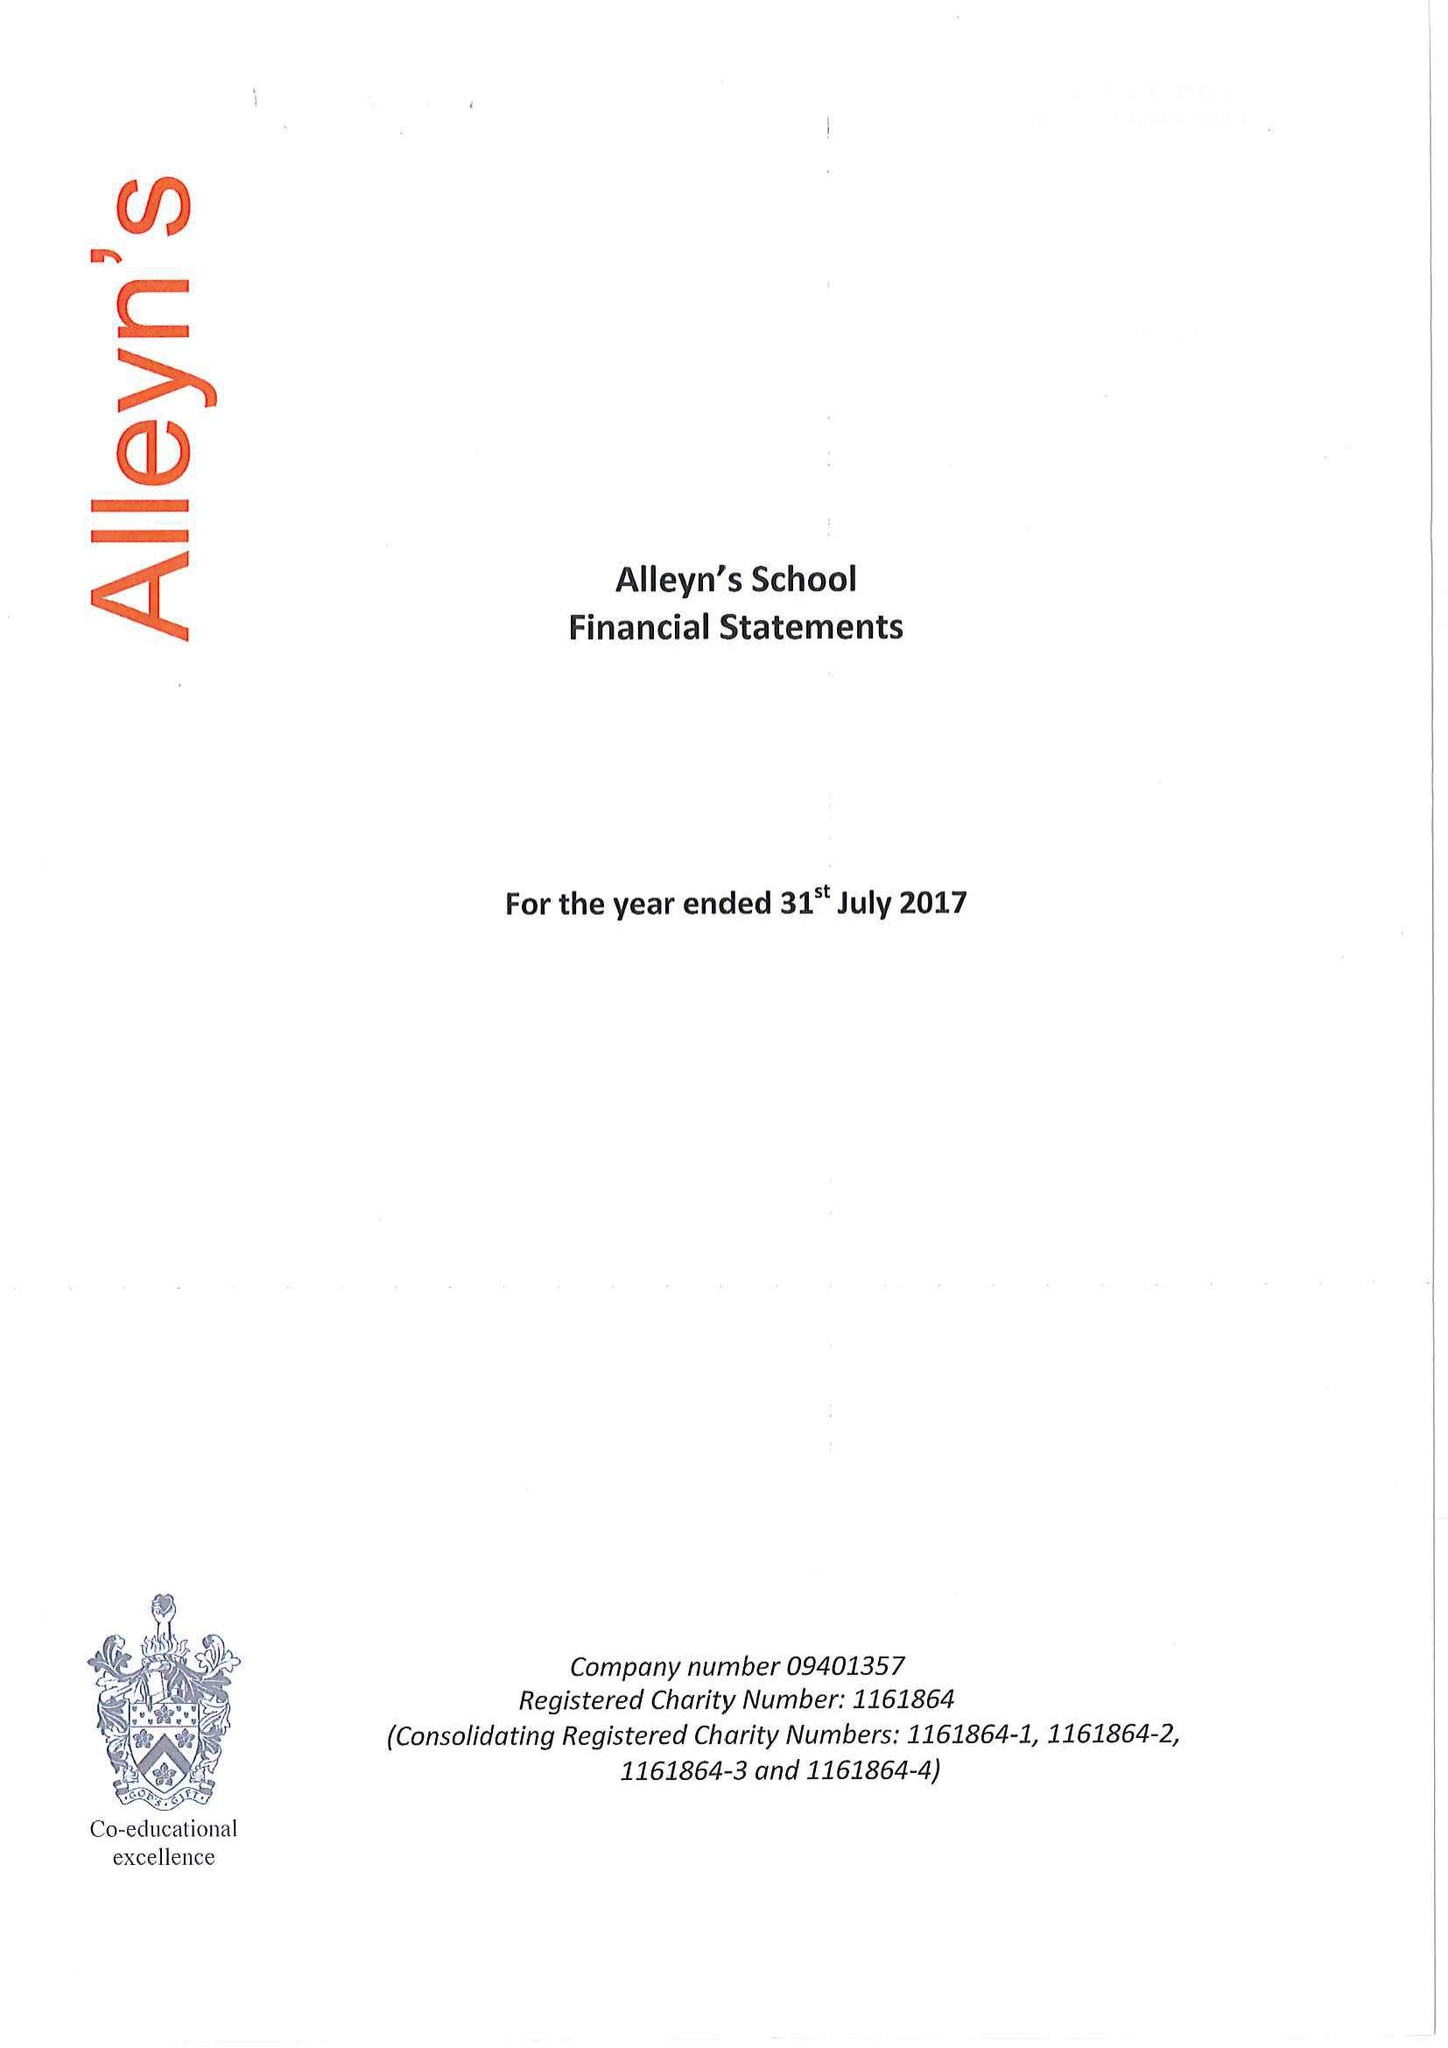What is the value for the report_date?
Answer the question using a single word or phrase. 2017-07-31 